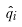Convert formula to latex. <formula><loc_0><loc_0><loc_500><loc_500>\hat { q } _ { i }</formula> 